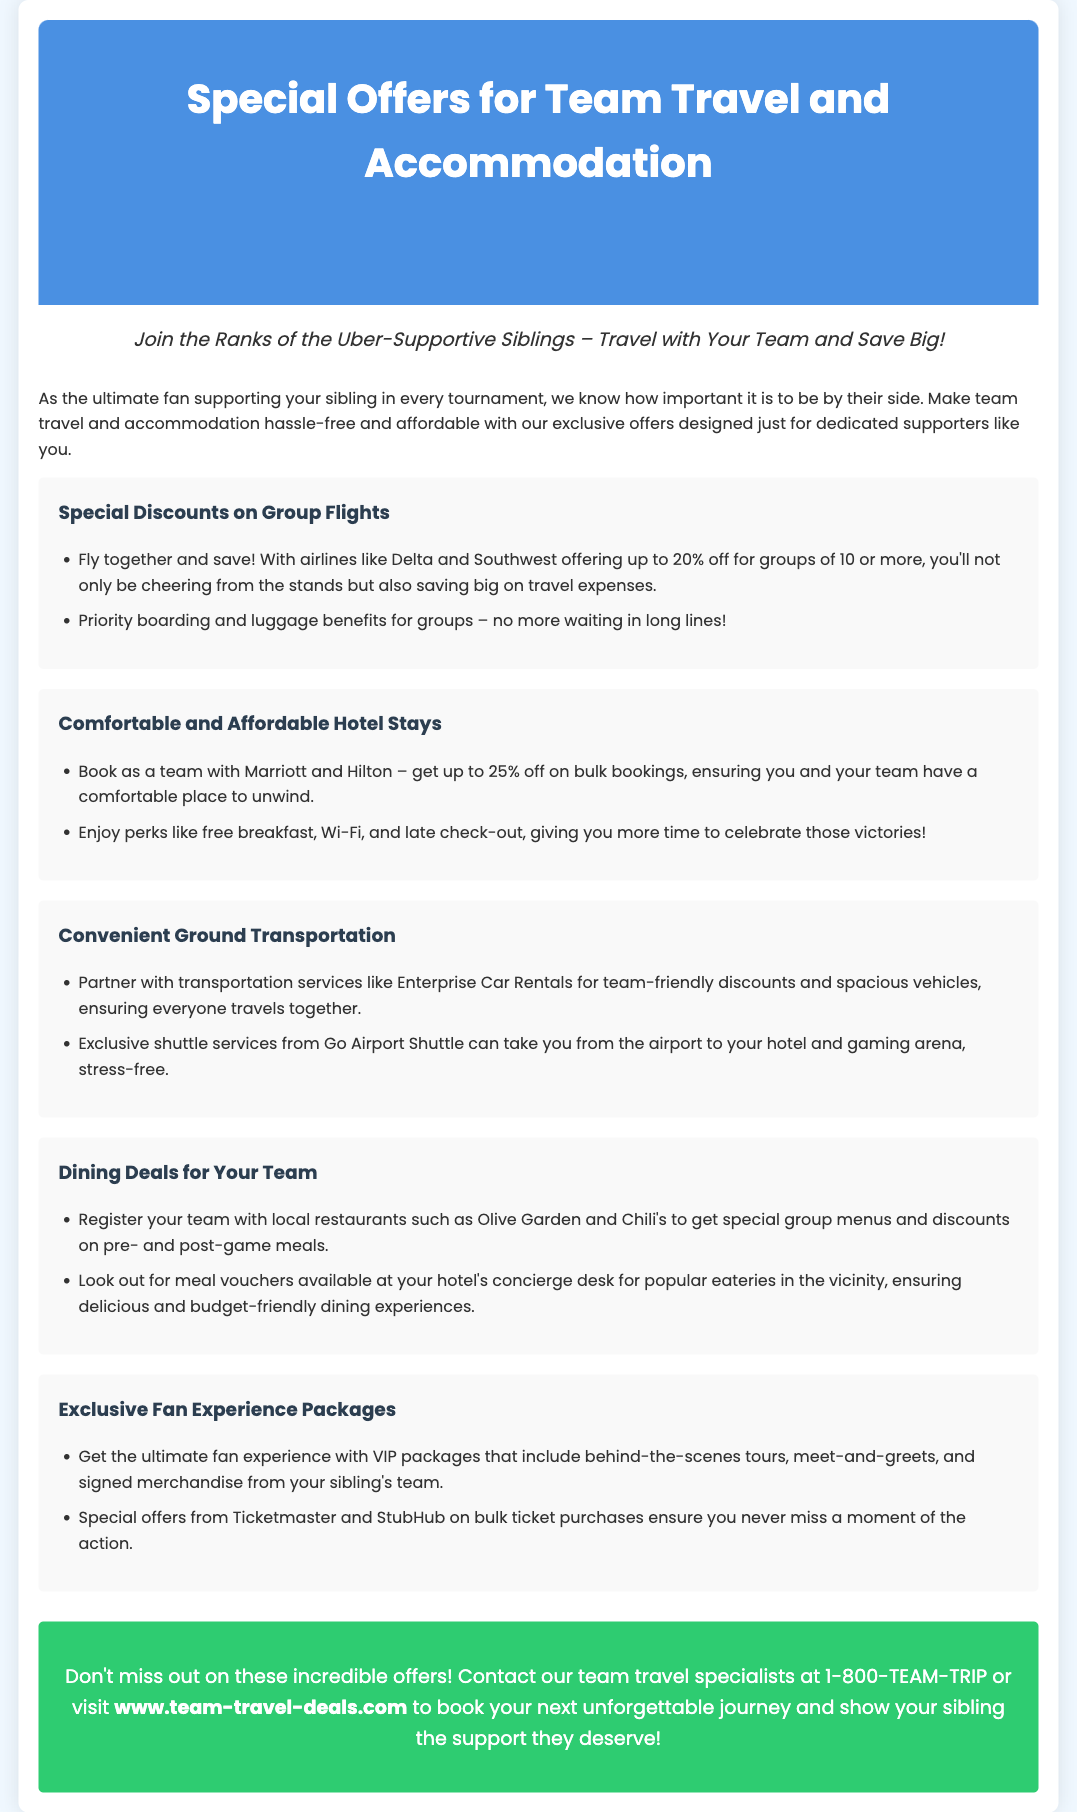What is the main focus of the advertisement? The advertisement focuses on special offers for team travel and accommodation for dedicated supporters.
Answer: Special offers for team travel and accommodation What discount can groups receive from airlines like Delta and Southwest? The document states that groups of 10 or more can receive a discount on airfare.
Answer: Up to 20% off Which hotel chains are mentioned for group discounts? The advertisement lists specific hotel chains offering discounts for group bookings.
Answer: Marriott and Hilton What service does Go Airport Shuttle provide? The document explains what service is offered by Go Airport Shuttle for the teams traveling.
Answer: Shuttle services What perks do hotel bookings with Marriott and Hilton include? The advertisement highlights additional benefits for hotel stays when booked as a team.
Answer: Free breakfast, Wi-Fi, and late check-out What type of discount is available for local restaurants? The document describes the kind of offers available to teams dining at local restaurants.
Answer: Special group menus and discounts How can fans enhance their experience according to the document? The advertisement describes additional options for fans wanting to engage more deeply with the events.
Answer: VIP packages What is the contact number for team travel specialists? The document provides contact information for booking travel assistance.
Answer: 1-800-TEAM-TRIP 